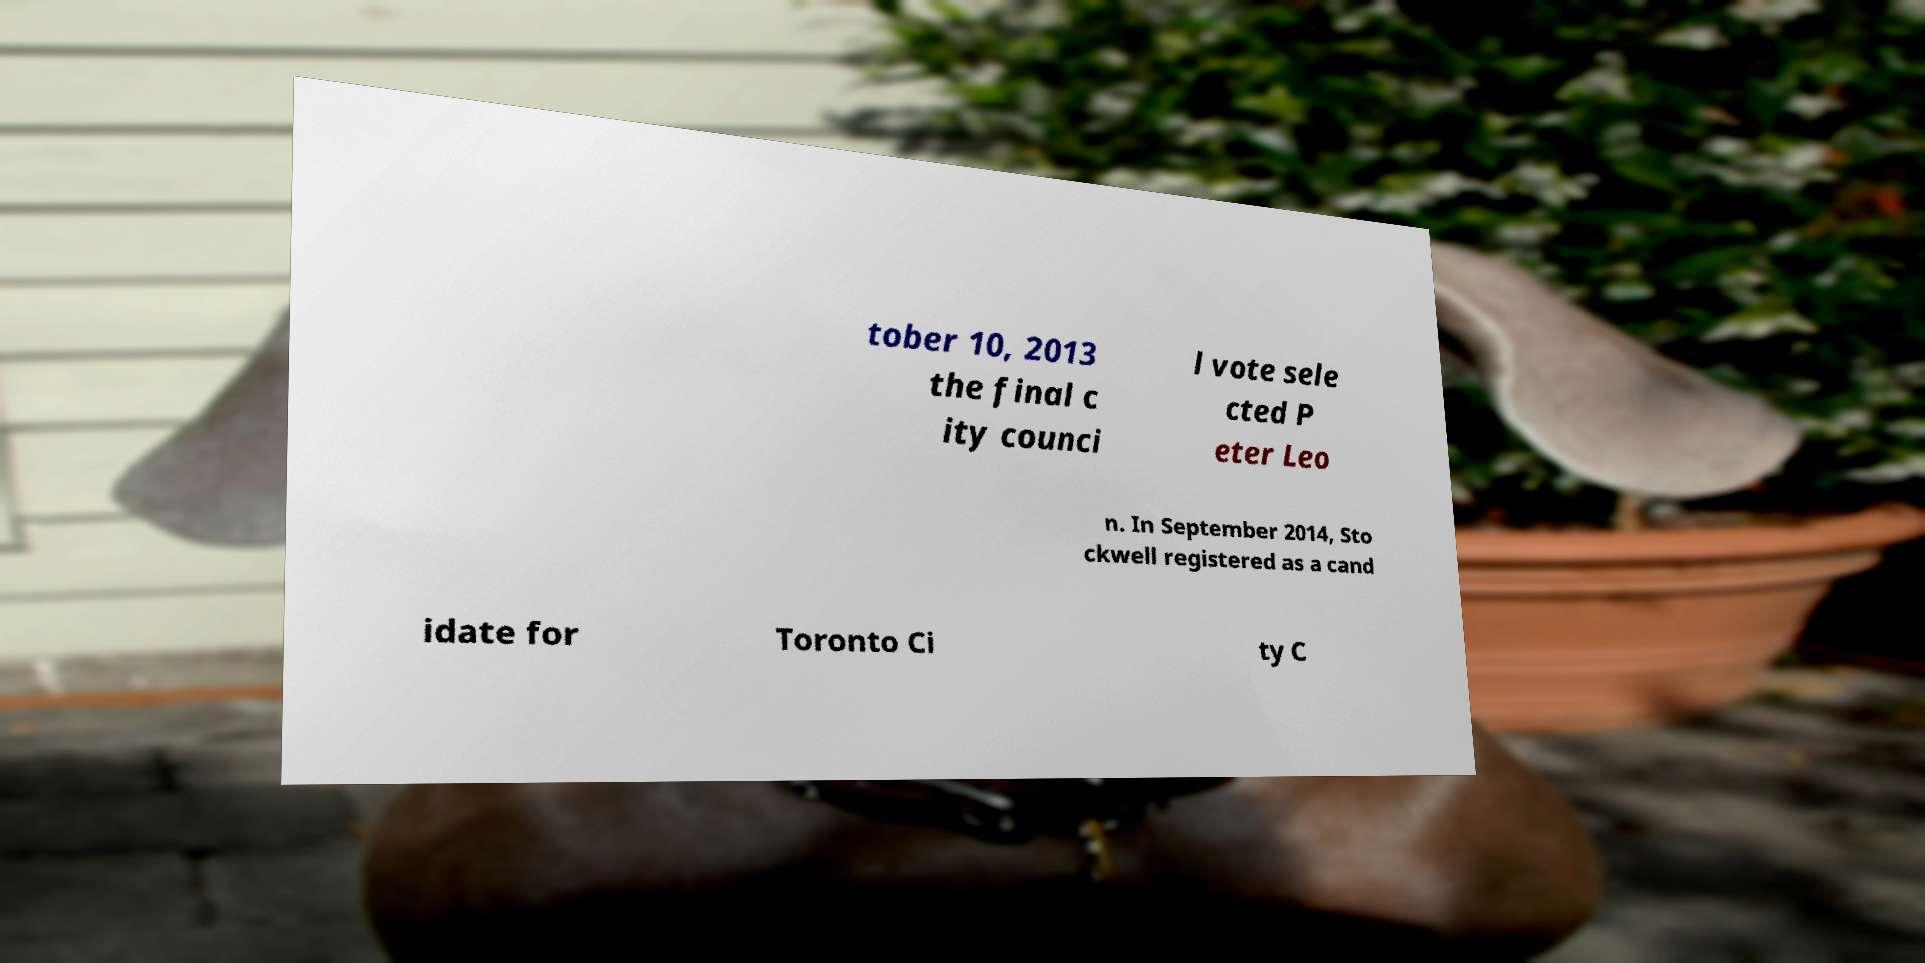What messages or text are displayed in this image? I need them in a readable, typed format. tober 10, 2013 the final c ity counci l vote sele cted P eter Leo n. In September 2014, Sto ckwell registered as a cand idate for Toronto Ci ty C 